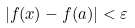Convert formula to latex. <formula><loc_0><loc_0><loc_500><loc_500>| f ( x ) - f ( a ) | < \varepsilon</formula> 